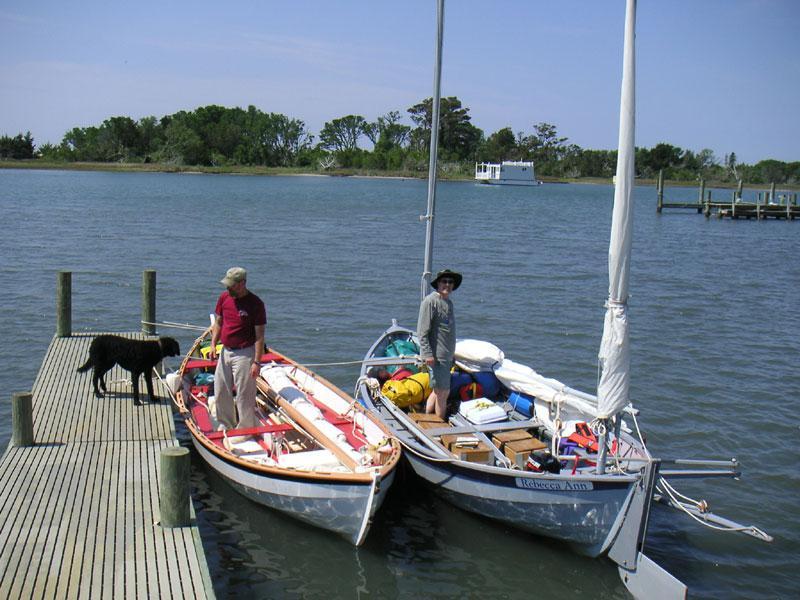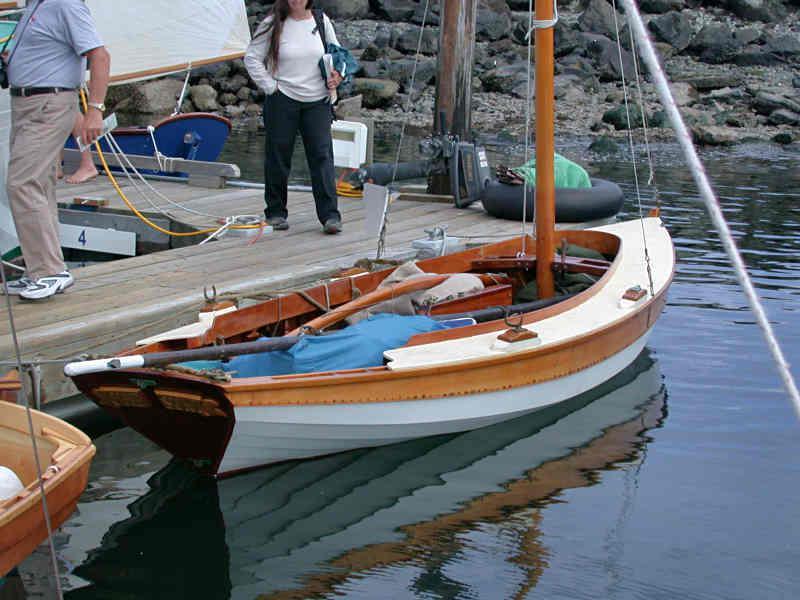The first image is the image on the left, the second image is the image on the right. For the images shown, is this caption "People are in two boats in the water in the image on the left." true? Answer yes or no. Yes. 